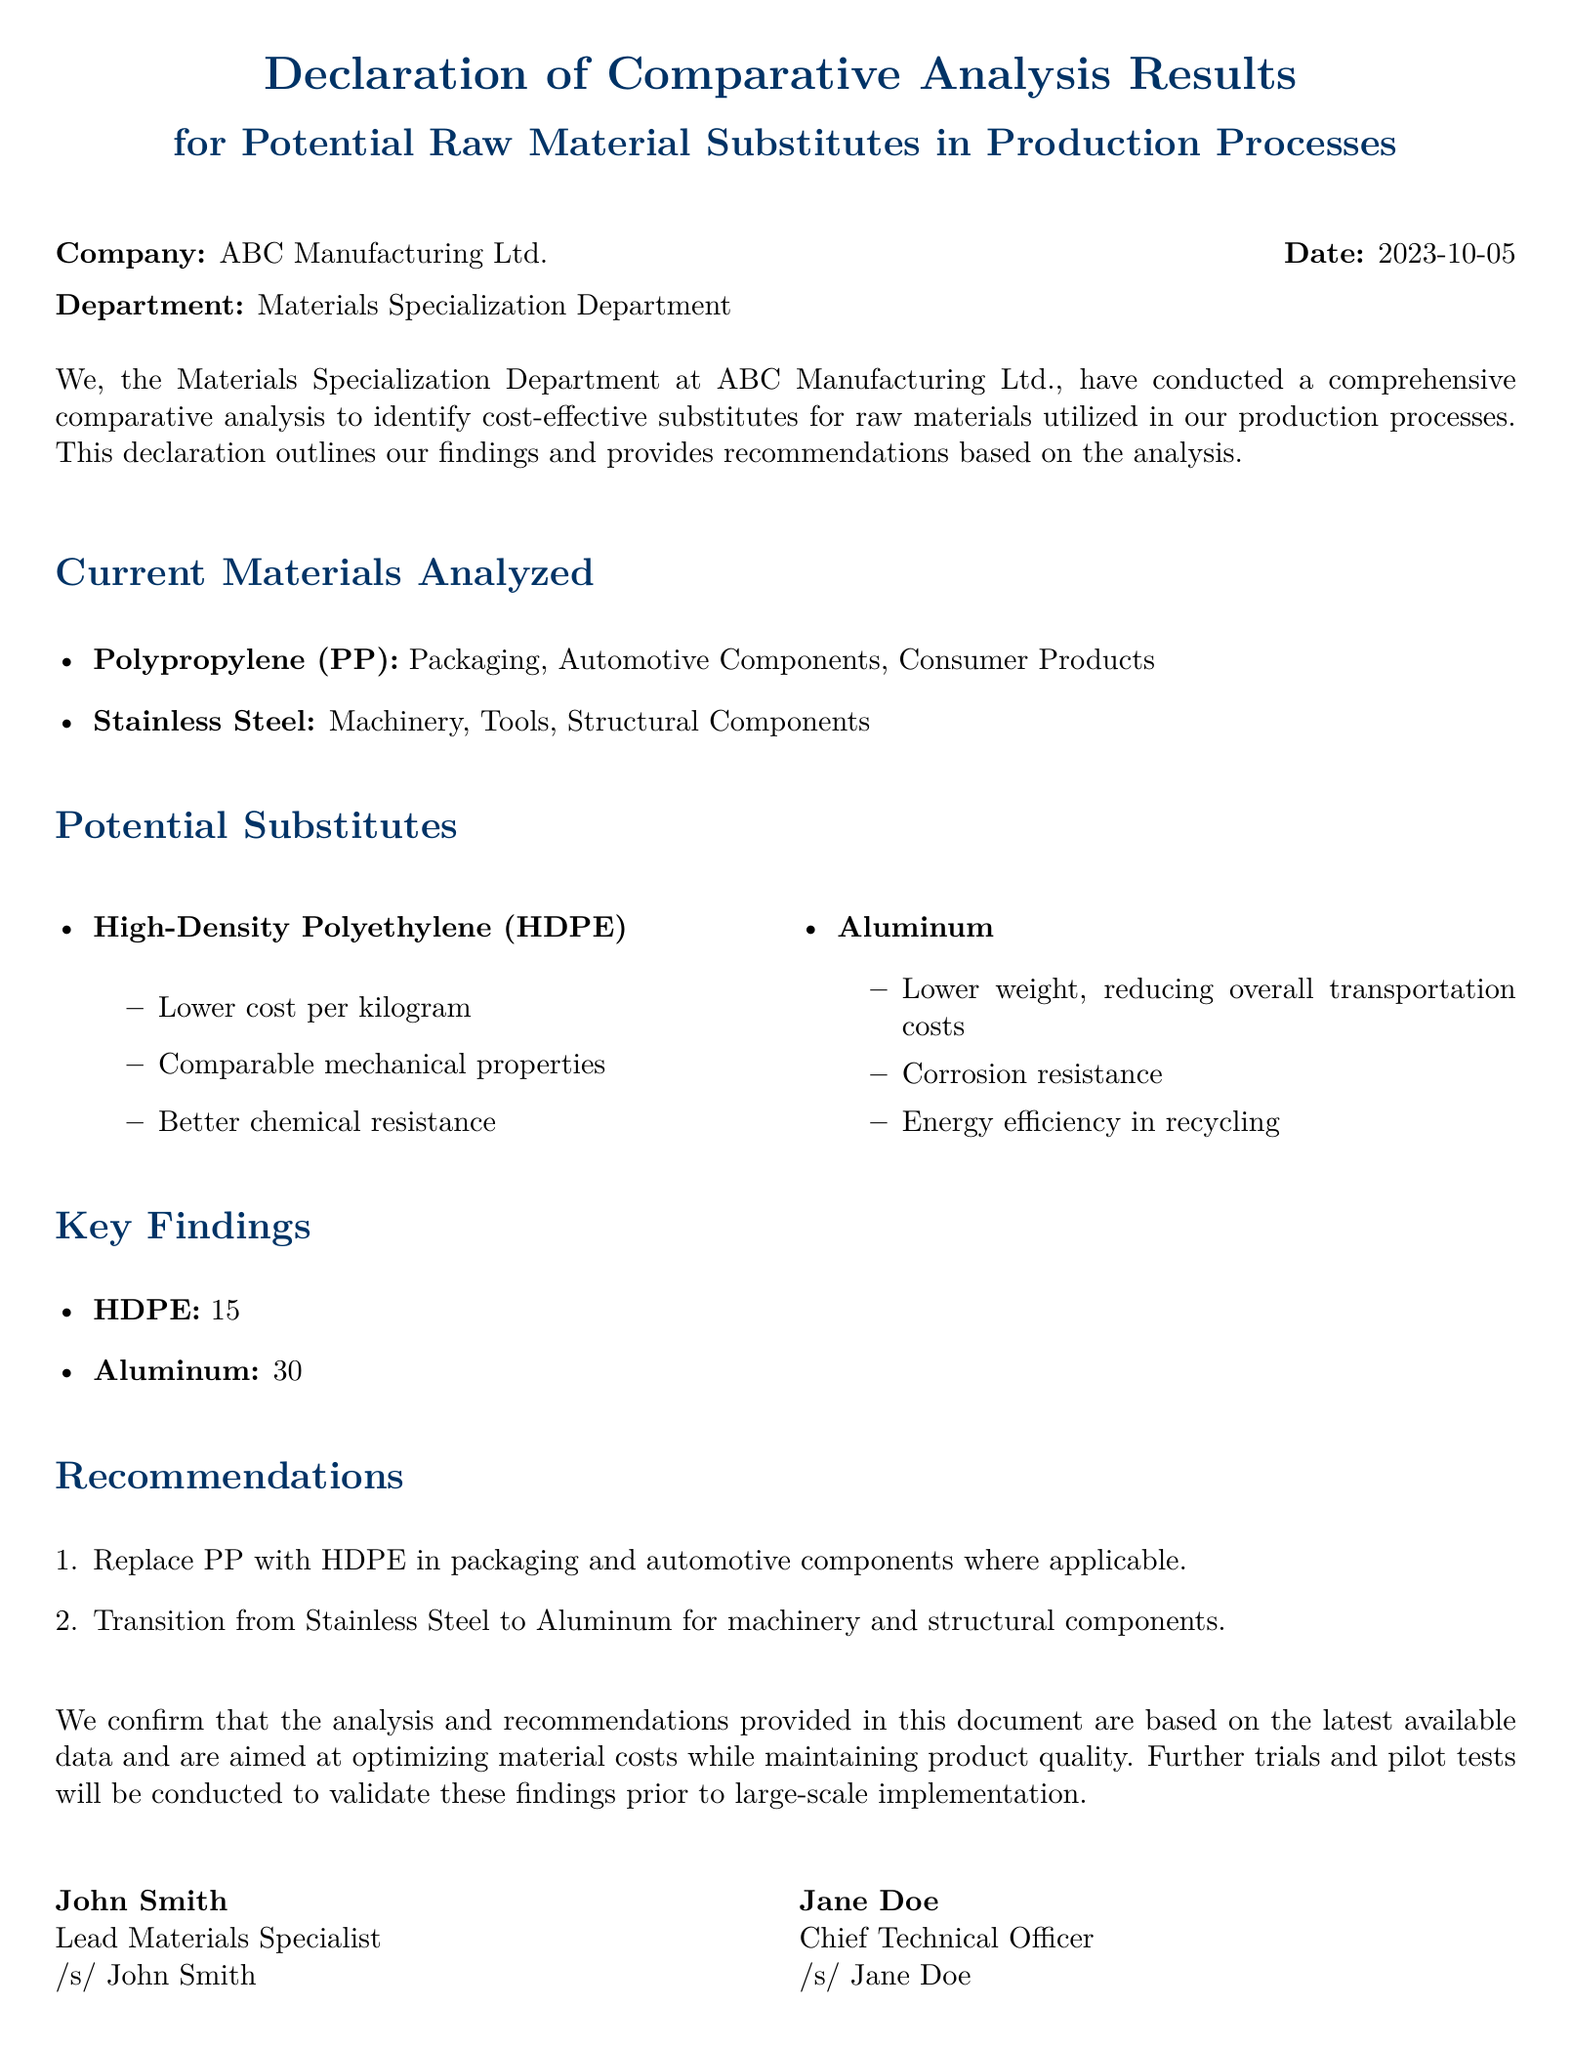what is the company name? The company name is mentioned at the beginning of the document.
Answer: ABC Manufacturing Ltd what is the date of the declaration? The date is specified alongside the company name.
Answer: 2023-10-05 who is the Lead Materials Specialist? The name of the Lead Materials Specialist is signed at the end of the document.
Answer: John Smith what are the current materials analyzed? The current materials are listed in the specific section of the document.
Answer: Polypropylene and Stainless Steel what is the cost reduction percentage of HDPE compared to PP? This figure is provided under key findings.
Answer: 15% what is the weight reduction percentage of Aluminum compared to Stainless Steel? This information is found in the key findings section of the document.
Answer: 50% what is one recommendation made in the document? Recommendations are provided in a list format in the document.
Answer: Replace PP with HDPE what is the department that conducted the analysis? The department is stated at the beginning of the document.
Answer: Materials Specialization Department what material should be transitioned for machinery and structural components? This detail is provided in the recommendations section.
Answer: Aluminum 